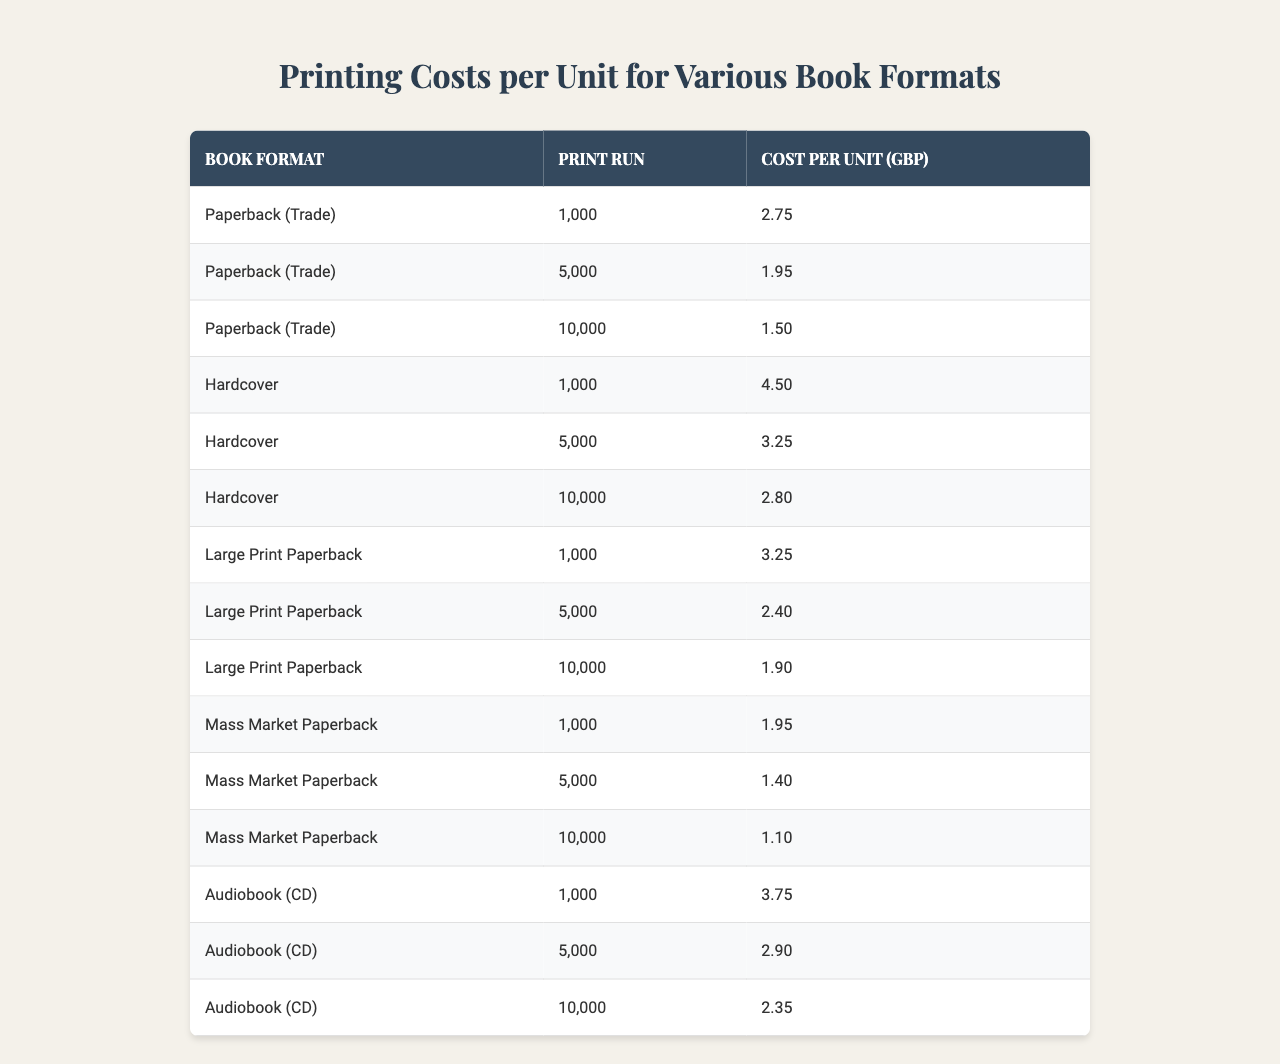What is the cost per unit for a hardcover book with a print run of 10,000? According to the table, the cost per unit for a hardcover book with a print run of 10,000 is listed directly in the relevant row.
Answer: 2.80 GBP Which book format has the lowest cost per unit at a print run of 5,000? By examining the table, we compare the cost per unit for all formats at a print run of 5,000. The format with the lowest cost is the Mass Market Paperback, which costs 1.40 GBP.
Answer: Mass Market Paperback What is the average cost per unit for paperback books across all print runs? To find the average, we first collect the costs for all paperback formats: 2.75, 1.95, 1.50, 3.25, 2.40, and 1.90. There are 6 values, and their sum is 13.70. Dividing this by 6 gives us the average: 13.70 / 6 = 2.28 GBP.
Answer: 2.28 GBP Is the cost per unit for an audiobook at a print run of 1,000 more expensive than that of a large print paperback at the same quantity? Referring to the table, the cost per unit for an audiobook at a print run of 1,000 is 3.75 GBP, while the cost for a large print paperback is 3.25 GBP. Since 3.75 is greater than 3.25, the audiobook is indeed more expensive.
Answer: Yes What is the difference in cost per unit between a mass market paperback and a hardcover at a print run of 10,000? We subtract the cost per unit of the mass market paperback (1.10 GBP) from that of the hardcover (2.80 GBP) at a print run of 10,000. The difference is: 2.80 - 1.10 = 1.70 GBP.
Answer: 1.70 GBP How do the printing costs compare between a paperback and a hardcover for a print run of 5,000? Looking at the table, the cost per unit for a paperback (1.95 GBP) is compared to a hardcover (3.25 GBP) at a print run of 5,000. The hardcover is more expensive by: 3.25 - 1.95 = 1.30 GBP.
Answer: 1.30 GBP Which book format consistently has the highest cost per unit across all print runs? By examining all entries in the table, we can see that the Hardcover format has the highest cost per unit at every print run listed (4.50, 3.25, and 2.80 GBP).
Answer: Hardcover What is the total cost for producing 10,000 mass market paperbacks? The cost per unit for 10,000 mass market paperbacks is 1.10 GBP. To find the total cost, we multiply this by 10,000: 1.10 x 10,000 = 11,000 GBP.
Answer: 11,000 GBP Is there any book format that has the same cost per unit for different print runs? By analyzing the table, we check for repeating cost per units for different formats and print runs. None of the formats show the same cost per unit across any print runs, so the answer is no.
Answer: No Which format offers the best savings per unit as the print run increases from 1,000 to 10,000? For each format, we can calculate the savings per unit by subtracting the cost for 10,000 from that of 1,000. For example, the cost saving for the paperback (2.75 - 1.50) is 1.25, for hardcover (4.50 - 2.80) is 1.70, etc. The largest saving is from the hardcover, which shows the greatest difference.
Answer: Hardcover 